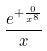Convert formula to latex. <formula><loc_0><loc_0><loc_500><loc_500>\frac { e ^ { + \frac { 0 } { x ^ { 8 } } } } { x }</formula> 